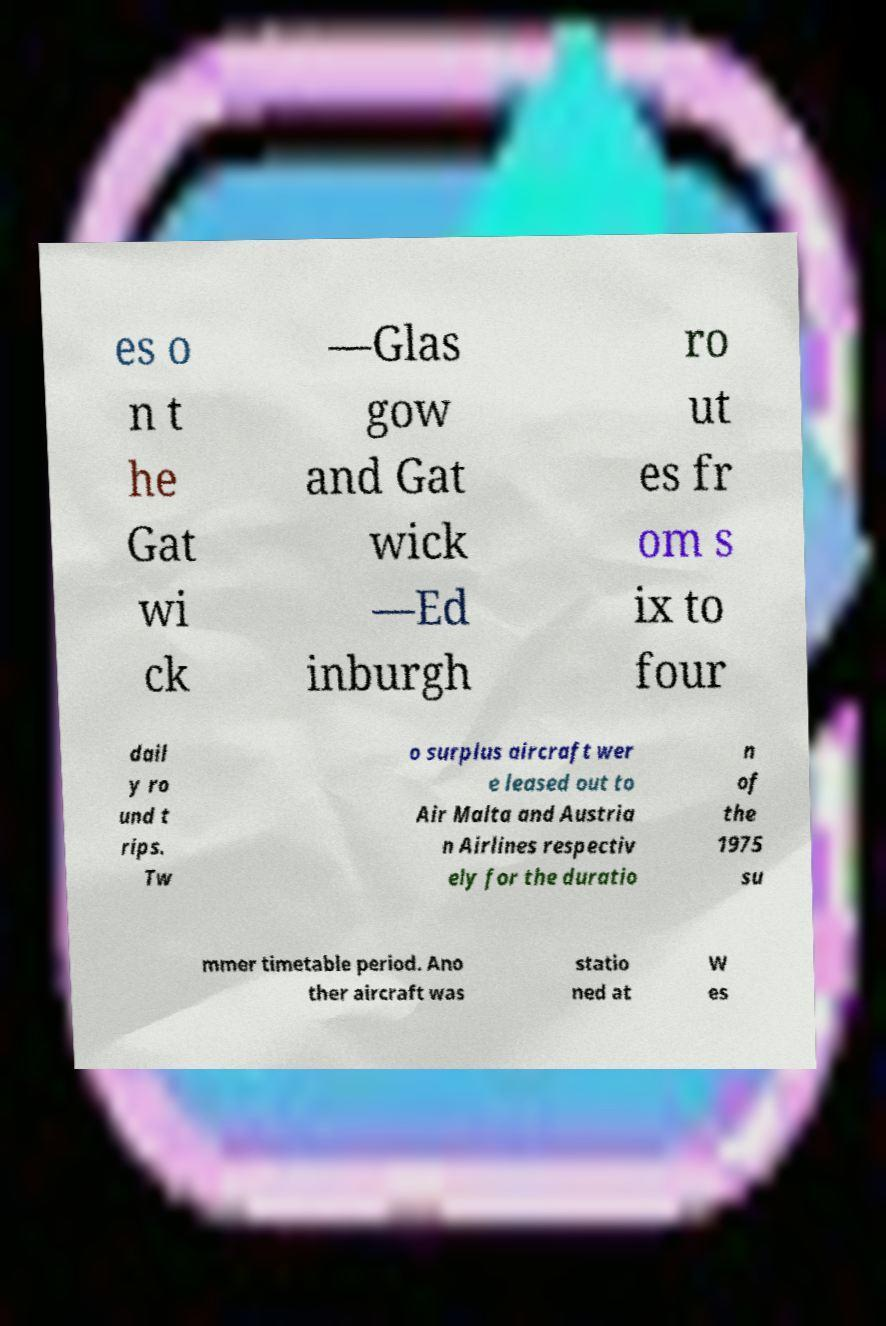There's text embedded in this image that I need extracted. Can you transcribe it verbatim? es o n t he Gat wi ck —Glas gow and Gat wick —Ed inburgh ro ut es fr om s ix to four dail y ro und t rips. Tw o surplus aircraft wer e leased out to Air Malta and Austria n Airlines respectiv ely for the duratio n of the 1975 su mmer timetable period. Ano ther aircraft was statio ned at W es 